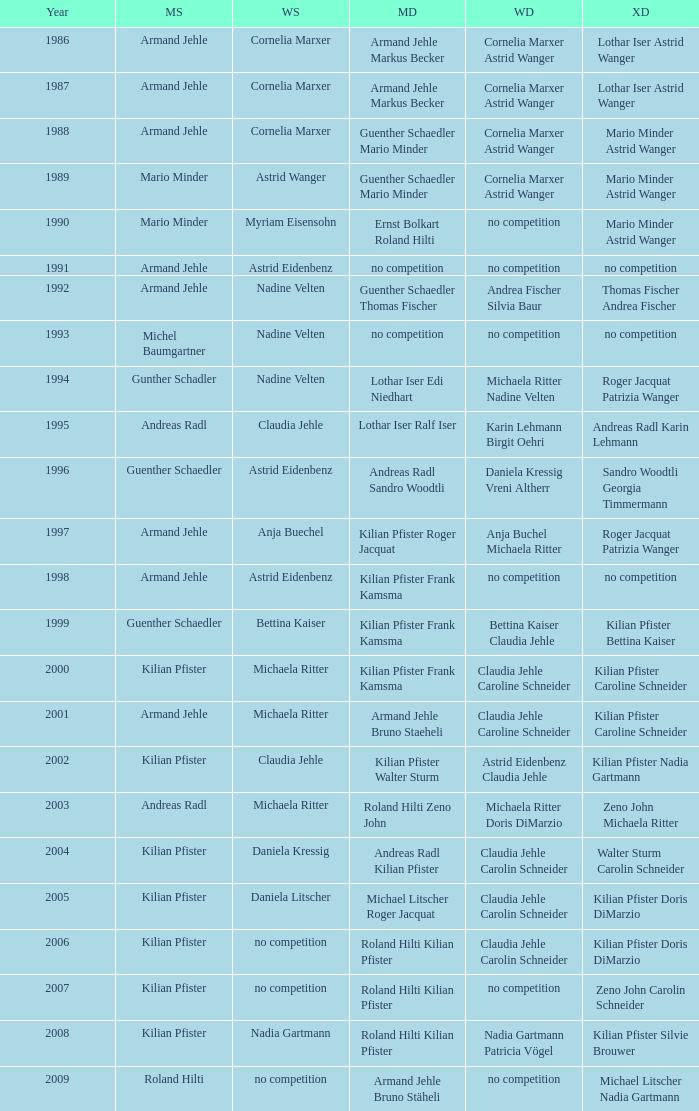In 2004, where the womens singles is daniela kressig who is the mens singles Kilian Pfister. Would you mind parsing the complete table? {'header': ['Year', 'MS', 'WS', 'MD', 'WD', 'XD'], 'rows': [['1986', 'Armand Jehle', 'Cornelia Marxer', 'Armand Jehle Markus Becker', 'Cornelia Marxer Astrid Wanger', 'Lothar Iser Astrid Wanger'], ['1987', 'Armand Jehle', 'Cornelia Marxer', 'Armand Jehle Markus Becker', 'Cornelia Marxer Astrid Wanger', 'Lothar Iser Astrid Wanger'], ['1988', 'Armand Jehle', 'Cornelia Marxer', 'Guenther Schaedler Mario Minder', 'Cornelia Marxer Astrid Wanger', 'Mario Minder Astrid Wanger'], ['1989', 'Mario Minder', 'Astrid Wanger', 'Guenther Schaedler Mario Minder', 'Cornelia Marxer Astrid Wanger', 'Mario Minder Astrid Wanger'], ['1990', 'Mario Minder', 'Myriam Eisensohn', 'Ernst Bolkart Roland Hilti', 'no competition', 'Mario Minder Astrid Wanger'], ['1991', 'Armand Jehle', 'Astrid Eidenbenz', 'no competition', 'no competition', 'no competition'], ['1992', 'Armand Jehle', 'Nadine Velten', 'Guenther Schaedler Thomas Fischer', 'Andrea Fischer Silvia Baur', 'Thomas Fischer Andrea Fischer'], ['1993', 'Michel Baumgartner', 'Nadine Velten', 'no competition', 'no competition', 'no competition'], ['1994', 'Gunther Schadler', 'Nadine Velten', 'Lothar Iser Edi Niedhart', 'Michaela Ritter Nadine Velten', 'Roger Jacquat Patrizia Wanger'], ['1995', 'Andreas Radl', 'Claudia Jehle', 'Lothar Iser Ralf Iser', 'Karin Lehmann Birgit Oehri', 'Andreas Radl Karin Lehmann'], ['1996', 'Guenther Schaedler', 'Astrid Eidenbenz', 'Andreas Radl Sandro Woodtli', 'Daniela Kressig Vreni Altherr', 'Sandro Woodtli Georgia Timmermann'], ['1997', 'Armand Jehle', 'Anja Buechel', 'Kilian Pfister Roger Jacquat', 'Anja Buchel Michaela Ritter', 'Roger Jacquat Patrizia Wanger'], ['1998', 'Armand Jehle', 'Astrid Eidenbenz', 'Kilian Pfister Frank Kamsma', 'no competition', 'no competition'], ['1999', 'Guenther Schaedler', 'Bettina Kaiser', 'Kilian Pfister Frank Kamsma', 'Bettina Kaiser Claudia Jehle', 'Kilian Pfister Bettina Kaiser'], ['2000', 'Kilian Pfister', 'Michaela Ritter', 'Kilian Pfister Frank Kamsma', 'Claudia Jehle Caroline Schneider', 'Kilian Pfister Caroline Schneider'], ['2001', 'Armand Jehle', 'Michaela Ritter', 'Armand Jehle Bruno Staeheli', 'Claudia Jehle Caroline Schneider', 'Kilian Pfister Caroline Schneider'], ['2002', 'Kilian Pfister', 'Claudia Jehle', 'Kilian Pfister Walter Sturm', 'Astrid Eidenbenz Claudia Jehle', 'Kilian Pfister Nadia Gartmann'], ['2003', 'Andreas Radl', 'Michaela Ritter', 'Roland Hilti Zeno John', 'Michaela Ritter Doris DiMarzio', 'Zeno John Michaela Ritter'], ['2004', 'Kilian Pfister', 'Daniela Kressig', 'Andreas Radl Kilian Pfister', 'Claudia Jehle Carolin Schneider', 'Walter Sturm Carolin Schneider'], ['2005', 'Kilian Pfister', 'Daniela Litscher', 'Michael Litscher Roger Jacquat', 'Claudia Jehle Carolin Schneider', 'Kilian Pfister Doris DiMarzio'], ['2006', 'Kilian Pfister', 'no competition', 'Roland Hilti Kilian Pfister', 'Claudia Jehle Carolin Schneider', 'Kilian Pfister Doris DiMarzio'], ['2007', 'Kilian Pfister', 'no competition', 'Roland Hilti Kilian Pfister', 'no competition', 'Zeno John Carolin Schneider'], ['2008', 'Kilian Pfister', 'Nadia Gartmann', 'Roland Hilti Kilian Pfister', 'Nadia Gartmann Patricia Vögel', 'Kilian Pfister Silvie Brouwer'], ['2009', 'Roland Hilti', 'no competition', 'Armand Jehle Bruno Stäheli', 'no competition', 'Michael Litscher Nadia Gartmann']]} 